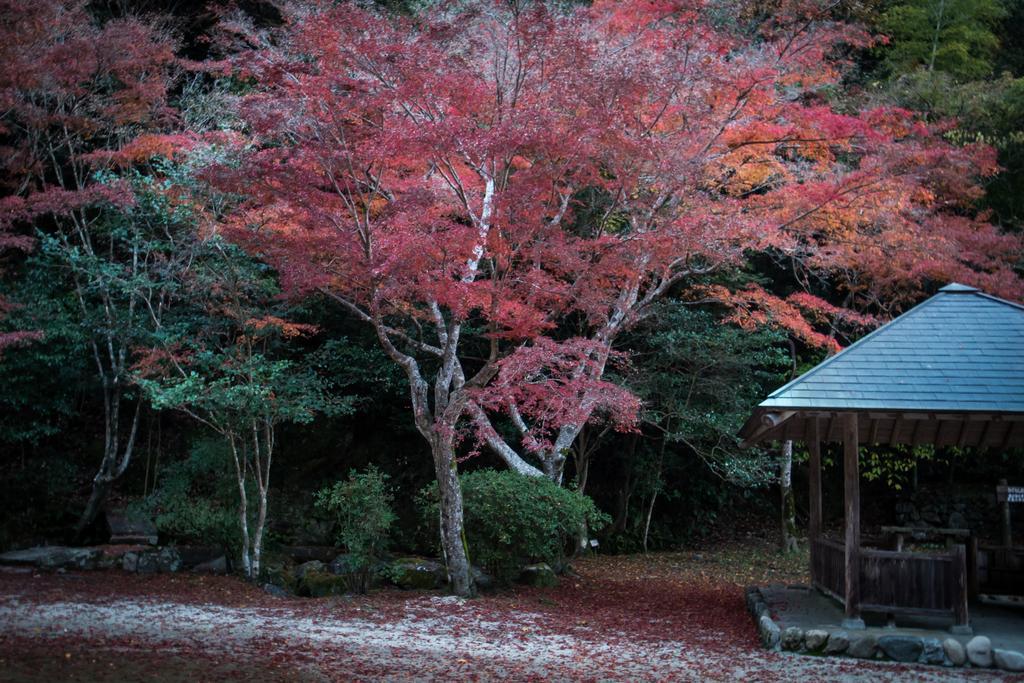In one or two sentences, can you explain what this image depicts? In this image we can see a group of trees and plants. On the right side, we can see a shed. At the bottom we can see the leaves. 